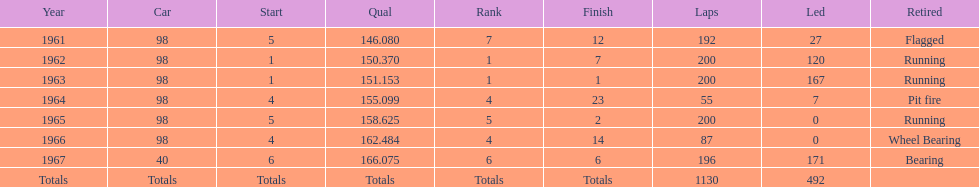In how many indy 500 contests, has jones been flagged? 1. 